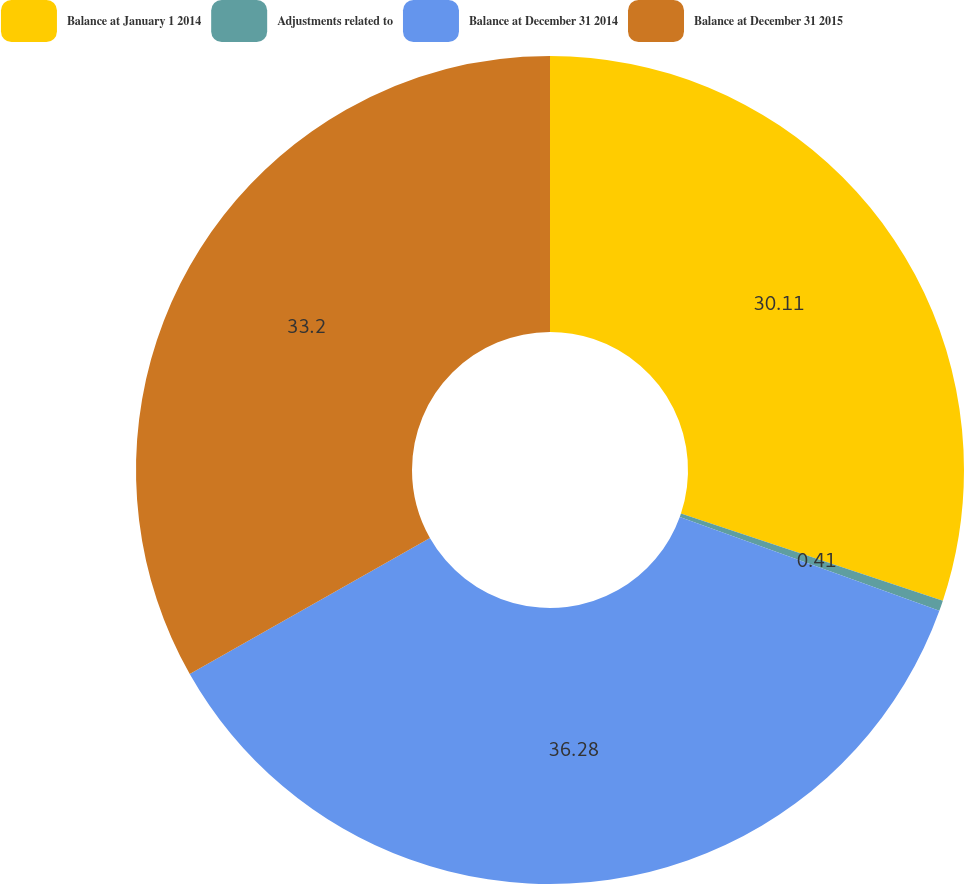Convert chart. <chart><loc_0><loc_0><loc_500><loc_500><pie_chart><fcel>Balance at January 1 2014<fcel>Adjustments related to<fcel>Balance at December 31 2014<fcel>Balance at December 31 2015<nl><fcel>30.11%<fcel>0.41%<fcel>36.28%<fcel>33.2%<nl></chart> 